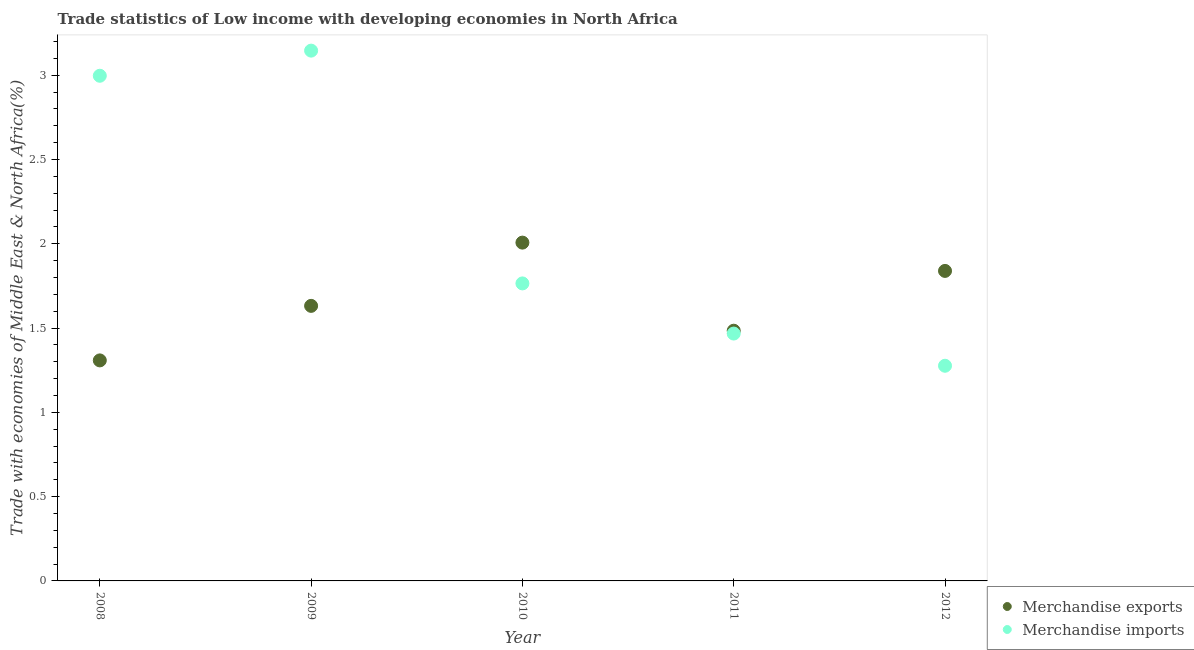How many different coloured dotlines are there?
Make the answer very short. 2. What is the merchandise imports in 2008?
Provide a short and direct response. 3. Across all years, what is the maximum merchandise exports?
Keep it short and to the point. 2.01. Across all years, what is the minimum merchandise imports?
Ensure brevity in your answer.  1.28. What is the total merchandise exports in the graph?
Offer a terse response. 8.27. What is the difference between the merchandise imports in 2010 and that in 2012?
Your answer should be compact. 0.49. What is the difference between the merchandise exports in 2010 and the merchandise imports in 2012?
Make the answer very short. 0.73. What is the average merchandise imports per year?
Ensure brevity in your answer.  2.13. In the year 2008, what is the difference between the merchandise imports and merchandise exports?
Provide a succinct answer. 1.69. What is the ratio of the merchandise imports in 2010 to that in 2011?
Offer a very short reply. 1.2. What is the difference between the highest and the second highest merchandise exports?
Provide a succinct answer. 0.17. What is the difference between the highest and the lowest merchandise exports?
Keep it short and to the point. 0.7. Is the sum of the merchandise exports in 2011 and 2012 greater than the maximum merchandise imports across all years?
Make the answer very short. Yes. Does the merchandise exports monotonically increase over the years?
Provide a short and direct response. No. Is the merchandise imports strictly greater than the merchandise exports over the years?
Your answer should be very brief. No. Is the merchandise exports strictly less than the merchandise imports over the years?
Provide a succinct answer. No. How many years are there in the graph?
Provide a succinct answer. 5. What is the difference between two consecutive major ticks on the Y-axis?
Give a very brief answer. 0.5. Does the graph contain grids?
Give a very brief answer. No. What is the title of the graph?
Ensure brevity in your answer.  Trade statistics of Low income with developing economies in North Africa. Does "GDP at market prices" appear as one of the legend labels in the graph?
Provide a succinct answer. No. What is the label or title of the Y-axis?
Your answer should be compact. Trade with economies of Middle East & North Africa(%). What is the Trade with economies of Middle East & North Africa(%) of Merchandise exports in 2008?
Make the answer very short. 1.31. What is the Trade with economies of Middle East & North Africa(%) in Merchandise imports in 2008?
Offer a very short reply. 3. What is the Trade with economies of Middle East & North Africa(%) of Merchandise exports in 2009?
Your answer should be very brief. 1.63. What is the Trade with economies of Middle East & North Africa(%) in Merchandise imports in 2009?
Give a very brief answer. 3.15. What is the Trade with economies of Middle East & North Africa(%) of Merchandise exports in 2010?
Keep it short and to the point. 2.01. What is the Trade with economies of Middle East & North Africa(%) in Merchandise imports in 2010?
Provide a succinct answer. 1.76. What is the Trade with economies of Middle East & North Africa(%) of Merchandise exports in 2011?
Offer a terse response. 1.48. What is the Trade with economies of Middle East & North Africa(%) of Merchandise imports in 2011?
Your answer should be very brief. 1.47. What is the Trade with economies of Middle East & North Africa(%) of Merchandise exports in 2012?
Your answer should be very brief. 1.84. What is the Trade with economies of Middle East & North Africa(%) of Merchandise imports in 2012?
Offer a very short reply. 1.28. Across all years, what is the maximum Trade with economies of Middle East & North Africa(%) of Merchandise exports?
Offer a very short reply. 2.01. Across all years, what is the maximum Trade with economies of Middle East & North Africa(%) of Merchandise imports?
Offer a very short reply. 3.15. Across all years, what is the minimum Trade with economies of Middle East & North Africa(%) in Merchandise exports?
Your answer should be very brief. 1.31. Across all years, what is the minimum Trade with economies of Middle East & North Africa(%) in Merchandise imports?
Provide a short and direct response. 1.28. What is the total Trade with economies of Middle East & North Africa(%) of Merchandise exports in the graph?
Offer a very short reply. 8.27. What is the total Trade with economies of Middle East & North Africa(%) in Merchandise imports in the graph?
Ensure brevity in your answer.  10.65. What is the difference between the Trade with economies of Middle East & North Africa(%) of Merchandise exports in 2008 and that in 2009?
Ensure brevity in your answer.  -0.32. What is the difference between the Trade with economies of Middle East & North Africa(%) of Merchandise imports in 2008 and that in 2009?
Ensure brevity in your answer.  -0.15. What is the difference between the Trade with economies of Middle East & North Africa(%) in Merchandise exports in 2008 and that in 2010?
Keep it short and to the point. -0.7. What is the difference between the Trade with economies of Middle East & North Africa(%) of Merchandise imports in 2008 and that in 2010?
Provide a succinct answer. 1.23. What is the difference between the Trade with economies of Middle East & North Africa(%) in Merchandise exports in 2008 and that in 2011?
Provide a succinct answer. -0.18. What is the difference between the Trade with economies of Middle East & North Africa(%) of Merchandise imports in 2008 and that in 2011?
Make the answer very short. 1.53. What is the difference between the Trade with economies of Middle East & North Africa(%) of Merchandise exports in 2008 and that in 2012?
Offer a very short reply. -0.53. What is the difference between the Trade with economies of Middle East & North Africa(%) of Merchandise imports in 2008 and that in 2012?
Provide a succinct answer. 1.72. What is the difference between the Trade with economies of Middle East & North Africa(%) of Merchandise exports in 2009 and that in 2010?
Give a very brief answer. -0.38. What is the difference between the Trade with economies of Middle East & North Africa(%) of Merchandise imports in 2009 and that in 2010?
Your answer should be compact. 1.38. What is the difference between the Trade with economies of Middle East & North Africa(%) in Merchandise exports in 2009 and that in 2011?
Offer a terse response. 0.15. What is the difference between the Trade with economies of Middle East & North Africa(%) in Merchandise imports in 2009 and that in 2011?
Offer a terse response. 1.68. What is the difference between the Trade with economies of Middle East & North Africa(%) of Merchandise exports in 2009 and that in 2012?
Provide a succinct answer. -0.21. What is the difference between the Trade with economies of Middle East & North Africa(%) of Merchandise imports in 2009 and that in 2012?
Give a very brief answer. 1.87. What is the difference between the Trade with economies of Middle East & North Africa(%) in Merchandise exports in 2010 and that in 2011?
Keep it short and to the point. 0.52. What is the difference between the Trade with economies of Middle East & North Africa(%) of Merchandise imports in 2010 and that in 2011?
Provide a succinct answer. 0.3. What is the difference between the Trade with economies of Middle East & North Africa(%) of Merchandise exports in 2010 and that in 2012?
Provide a succinct answer. 0.17. What is the difference between the Trade with economies of Middle East & North Africa(%) of Merchandise imports in 2010 and that in 2012?
Your answer should be compact. 0.49. What is the difference between the Trade with economies of Middle East & North Africa(%) of Merchandise exports in 2011 and that in 2012?
Offer a very short reply. -0.35. What is the difference between the Trade with economies of Middle East & North Africa(%) of Merchandise imports in 2011 and that in 2012?
Your answer should be compact. 0.19. What is the difference between the Trade with economies of Middle East & North Africa(%) of Merchandise exports in 2008 and the Trade with economies of Middle East & North Africa(%) of Merchandise imports in 2009?
Ensure brevity in your answer.  -1.84. What is the difference between the Trade with economies of Middle East & North Africa(%) in Merchandise exports in 2008 and the Trade with economies of Middle East & North Africa(%) in Merchandise imports in 2010?
Keep it short and to the point. -0.46. What is the difference between the Trade with economies of Middle East & North Africa(%) of Merchandise exports in 2008 and the Trade with economies of Middle East & North Africa(%) of Merchandise imports in 2011?
Provide a succinct answer. -0.16. What is the difference between the Trade with economies of Middle East & North Africa(%) of Merchandise exports in 2008 and the Trade with economies of Middle East & North Africa(%) of Merchandise imports in 2012?
Your answer should be compact. 0.03. What is the difference between the Trade with economies of Middle East & North Africa(%) of Merchandise exports in 2009 and the Trade with economies of Middle East & North Africa(%) of Merchandise imports in 2010?
Provide a short and direct response. -0.13. What is the difference between the Trade with economies of Middle East & North Africa(%) in Merchandise exports in 2009 and the Trade with economies of Middle East & North Africa(%) in Merchandise imports in 2011?
Ensure brevity in your answer.  0.16. What is the difference between the Trade with economies of Middle East & North Africa(%) of Merchandise exports in 2009 and the Trade with economies of Middle East & North Africa(%) of Merchandise imports in 2012?
Keep it short and to the point. 0.36. What is the difference between the Trade with economies of Middle East & North Africa(%) in Merchandise exports in 2010 and the Trade with economies of Middle East & North Africa(%) in Merchandise imports in 2011?
Offer a very short reply. 0.54. What is the difference between the Trade with economies of Middle East & North Africa(%) of Merchandise exports in 2010 and the Trade with economies of Middle East & North Africa(%) of Merchandise imports in 2012?
Provide a succinct answer. 0.73. What is the difference between the Trade with economies of Middle East & North Africa(%) in Merchandise exports in 2011 and the Trade with economies of Middle East & North Africa(%) in Merchandise imports in 2012?
Offer a terse response. 0.21. What is the average Trade with economies of Middle East & North Africa(%) of Merchandise exports per year?
Ensure brevity in your answer.  1.65. What is the average Trade with economies of Middle East & North Africa(%) in Merchandise imports per year?
Your response must be concise. 2.13. In the year 2008, what is the difference between the Trade with economies of Middle East & North Africa(%) in Merchandise exports and Trade with economies of Middle East & North Africa(%) in Merchandise imports?
Offer a very short reply. -1.69. In the year 2009, what is the difference between the Trade with economies of Middle East & North Africa(%) in Merchandise exports and Trade with economies of Middle East & North Africa(%) in Merchandise imports?
Offer a terse response. -1.51. In the year 2010, what is the difference between the Trade with economies of Middle East & North Africa(%) of Merchandise exports and Trade with economies of Middle East & North Africa(%) of Merchandise imports?
Make the answer very short. 0.24. In the year 2011, what is the difference between the Trade with economies of Middle East & North Africa(%) in Merchandise exports and Trade with economies of Middle East & North Africa(%) in Merchandise imports?
Make the answer very short. 0.02. In the year 2012, what is the difference between the Trade with economies of Middle East & North Africa(%) of Merchandise exports and Trade with economies of Middle East & North Africa(%) of Merchandise imports?
Give a very brief answer. 0.56. What is the ratio of the Trade with economies of Middle East & North Africa(%) in Merchandise exports in 2008 to that in 2009?
Give a very brief answer. 0.8. What is the ratio of the Trade with economies of Middle East & North Africa(%) in Merchandise imports in 2008 to that in 2009?
Your answer should be very brief. 0.95. What is the ratio of the Trade with economies of Middle East & North Africa(%) in Merchandise exports in 2008 to that in 2010?
Provide a short and direct response. 0.65. What is the ratio of the Trade with economies of Middle East & North Africa(%) of Merchandise imports in 2008 to that in 2010?
Your response must be concise. 1.7. What is the ratio of the Trade with economies of Middle East & North Africa(%) in Merchandise exports in 2008 to that in 2011?
Your answer should be compact. 0.88. What is the ratio of the Trade with economies of Middle East & North Africa(%) in Merchandise imports in 2008 to that in 2011?
Ensure brevity in your answer.  2.04. What is the ratio of the Trade with economies of Middle East & North Africa(%) of Merchandise exports in 2008 to that in 2012?
Offer a very short reply. 0.71. What is the ratio of the Trade with economies of Middle East & North Africa(%) of Merchandise imports in 2008 to that in 2012?
Offer a very short reply. 2.35. What is the ratio of the Trade with economies of Middle East & North Africa(%) in Merchandise exports in 2009 to that in 2010?
Your response must be concise. 0.81. What is the ratio of the Trade with economies of Middle East & North Africa(%) in Merchandise imports in 2009 to that in 2010?
Make the answer very short. 1.78. What is the ratio of the Trade with economies of Middle East & North Africa(%) of Merchandise exports in 2009 to that in 2011?
Keep it short and to the point. 1.1. What is the ratio of the Trade with economies of Middle East & North Africa(%) of Merchandise imports in 2009 to that in 2011?
Offer a terse response. 2.14. What is the ratio of the Trade with economies of Middle East & North Africa(%) in Merchandise exports in 2009 to that in 2012?
Ensure brevity in your answer.  0.89. What is the ratio of the Trade with economies of Middle East & North Africa(%) of Merchandise imports in 2009 to that in 2012?
Your response must be concise. 2.46. What is the ratio of the Trade with economies of Middle East & North Africa(%) of Merchandise exports in 2010 to that in 2011?
Keep it short and to the point. 1.35. What is the ratio of the Trade with economies of Middle East & North Africa(%) in Merchandise imports in 2010 to that in 2011?
Provide a succinct answer. 1.2. What is the ratio of the Trade with economies of Middle East & North Africa(%) in Merchandise exports in 2010 to that in 2012?
Offer a terse response. 1.09. What is the ratio of the Trade with economies of Middle East & North Africa(%) of Merchandise imports in 2010 to that in 2012?
Make the answer very short. 1.38. What is the ratio of the Trade with economies of Middle East & North Africa(%) in Merchandise exports in 2011 to that in 2012?
Offer a very short reply. 0.81. What is the ratio of the Trade with economies of Middle East & North Africa(%) in Merchandise imports in 2011 to that in 2012?
Your response must be concise. 1.15. What is the difference between the highest and the second highest Trade with economies of Middle East & North Africa(%) of Merchandise exports?
Keep it short and to the point. 0.17. What is the difference between the highest and the second highest Trade with economies of Middle East & North Africa(%) of Merchandise imports?
Make the answer very short. 0.15. What is the difference between the highest and the lowest Trade with economies of Middle East & North Africa(%) of Merchandise exports?
Keep it short and to the point. 0.7. What is the difference between the highest and the lowest Trade with economies of Middle East & North Africa(%) of Merchandise imports?
Give a very brief answer. 1.87. 